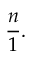Convert formula to latex. <formula><loc_0><loc_0><loc_500><loc_500>{ \frac { n } { 1 } } .</formula> 